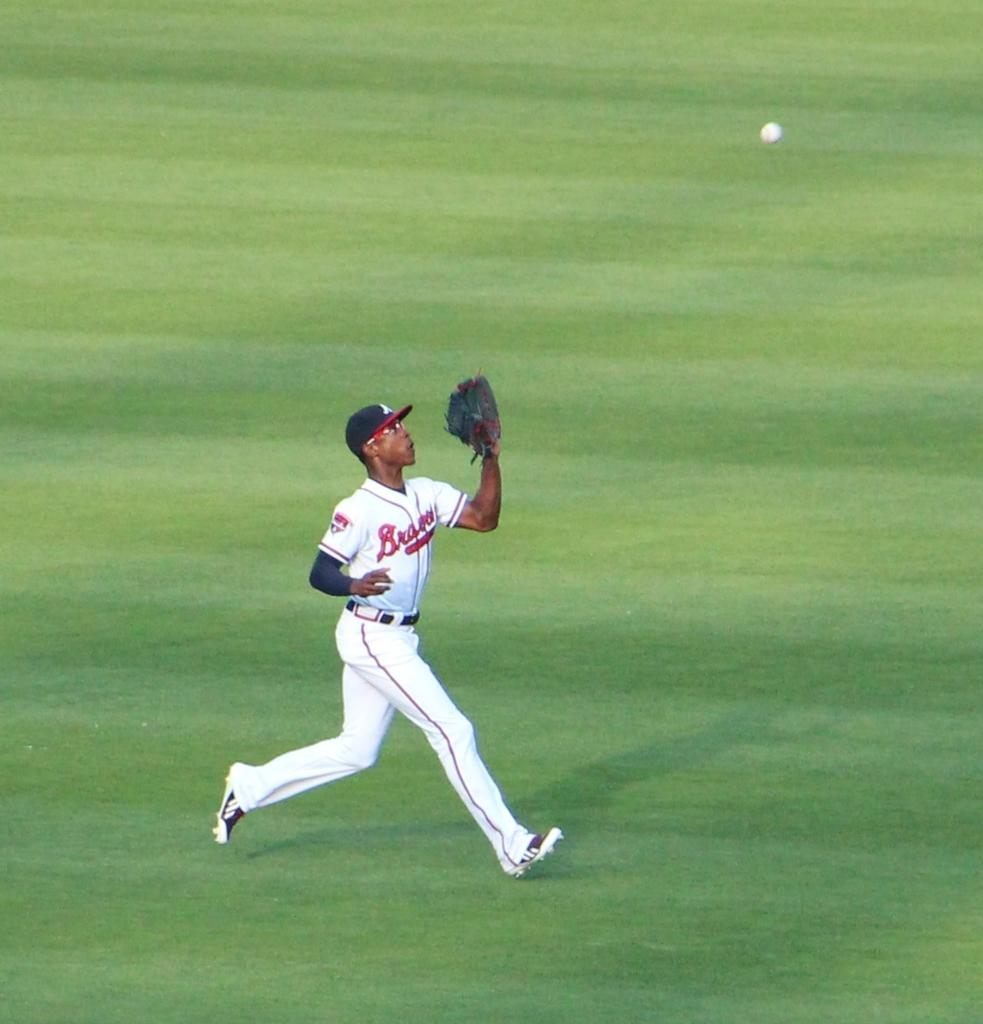What is the main subject of the image? There is a sportsman running in the image. Where is the sportsman located in the image? The sportsman is in the center of the image. What object is visible at the top of the image? There is a ball at the top of the image. What type of surface is at the bottom of the image? There is grass at the bottom of the image. Can you tell me where the brain of the sportsman is located in the image? There is no indication of the sportsman's brain in the image, as it is not visible. 